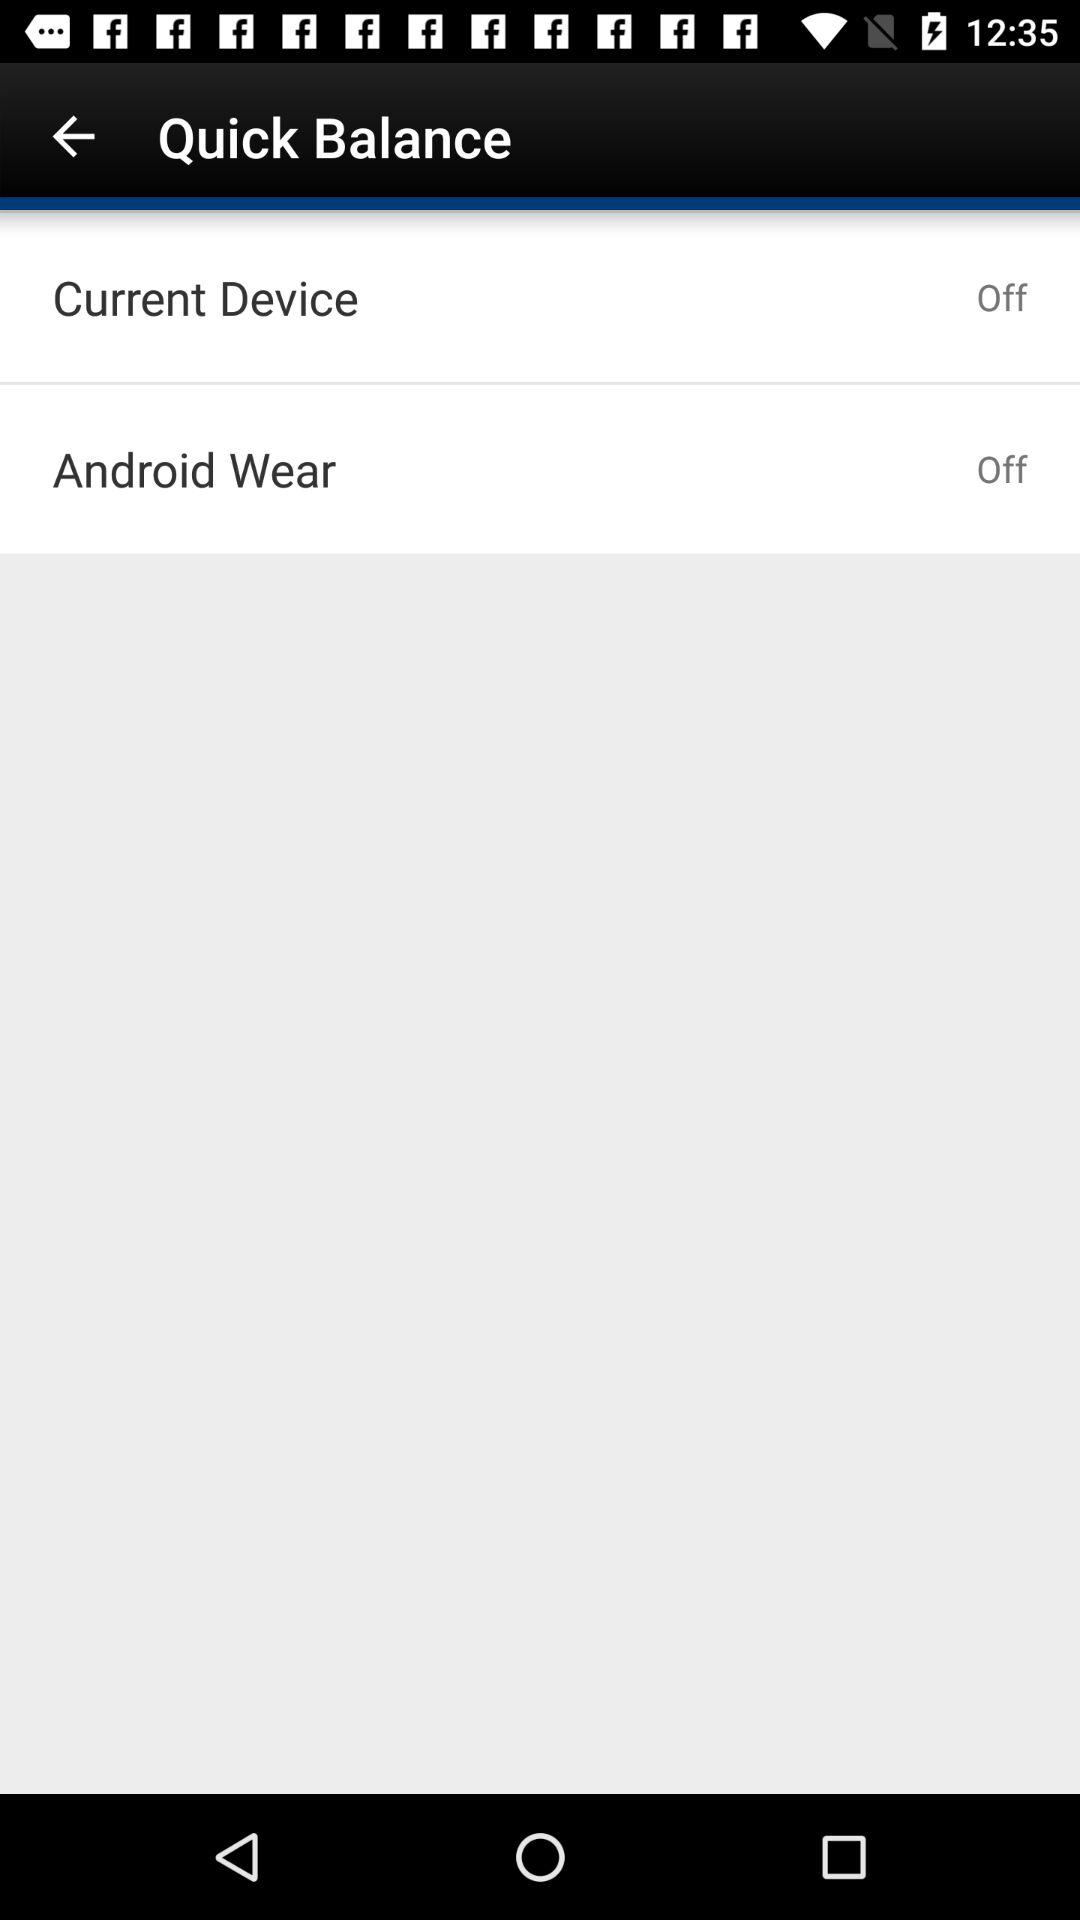What are the options available in the quick balance? The available options are "Current Device" and "Android Wear". 